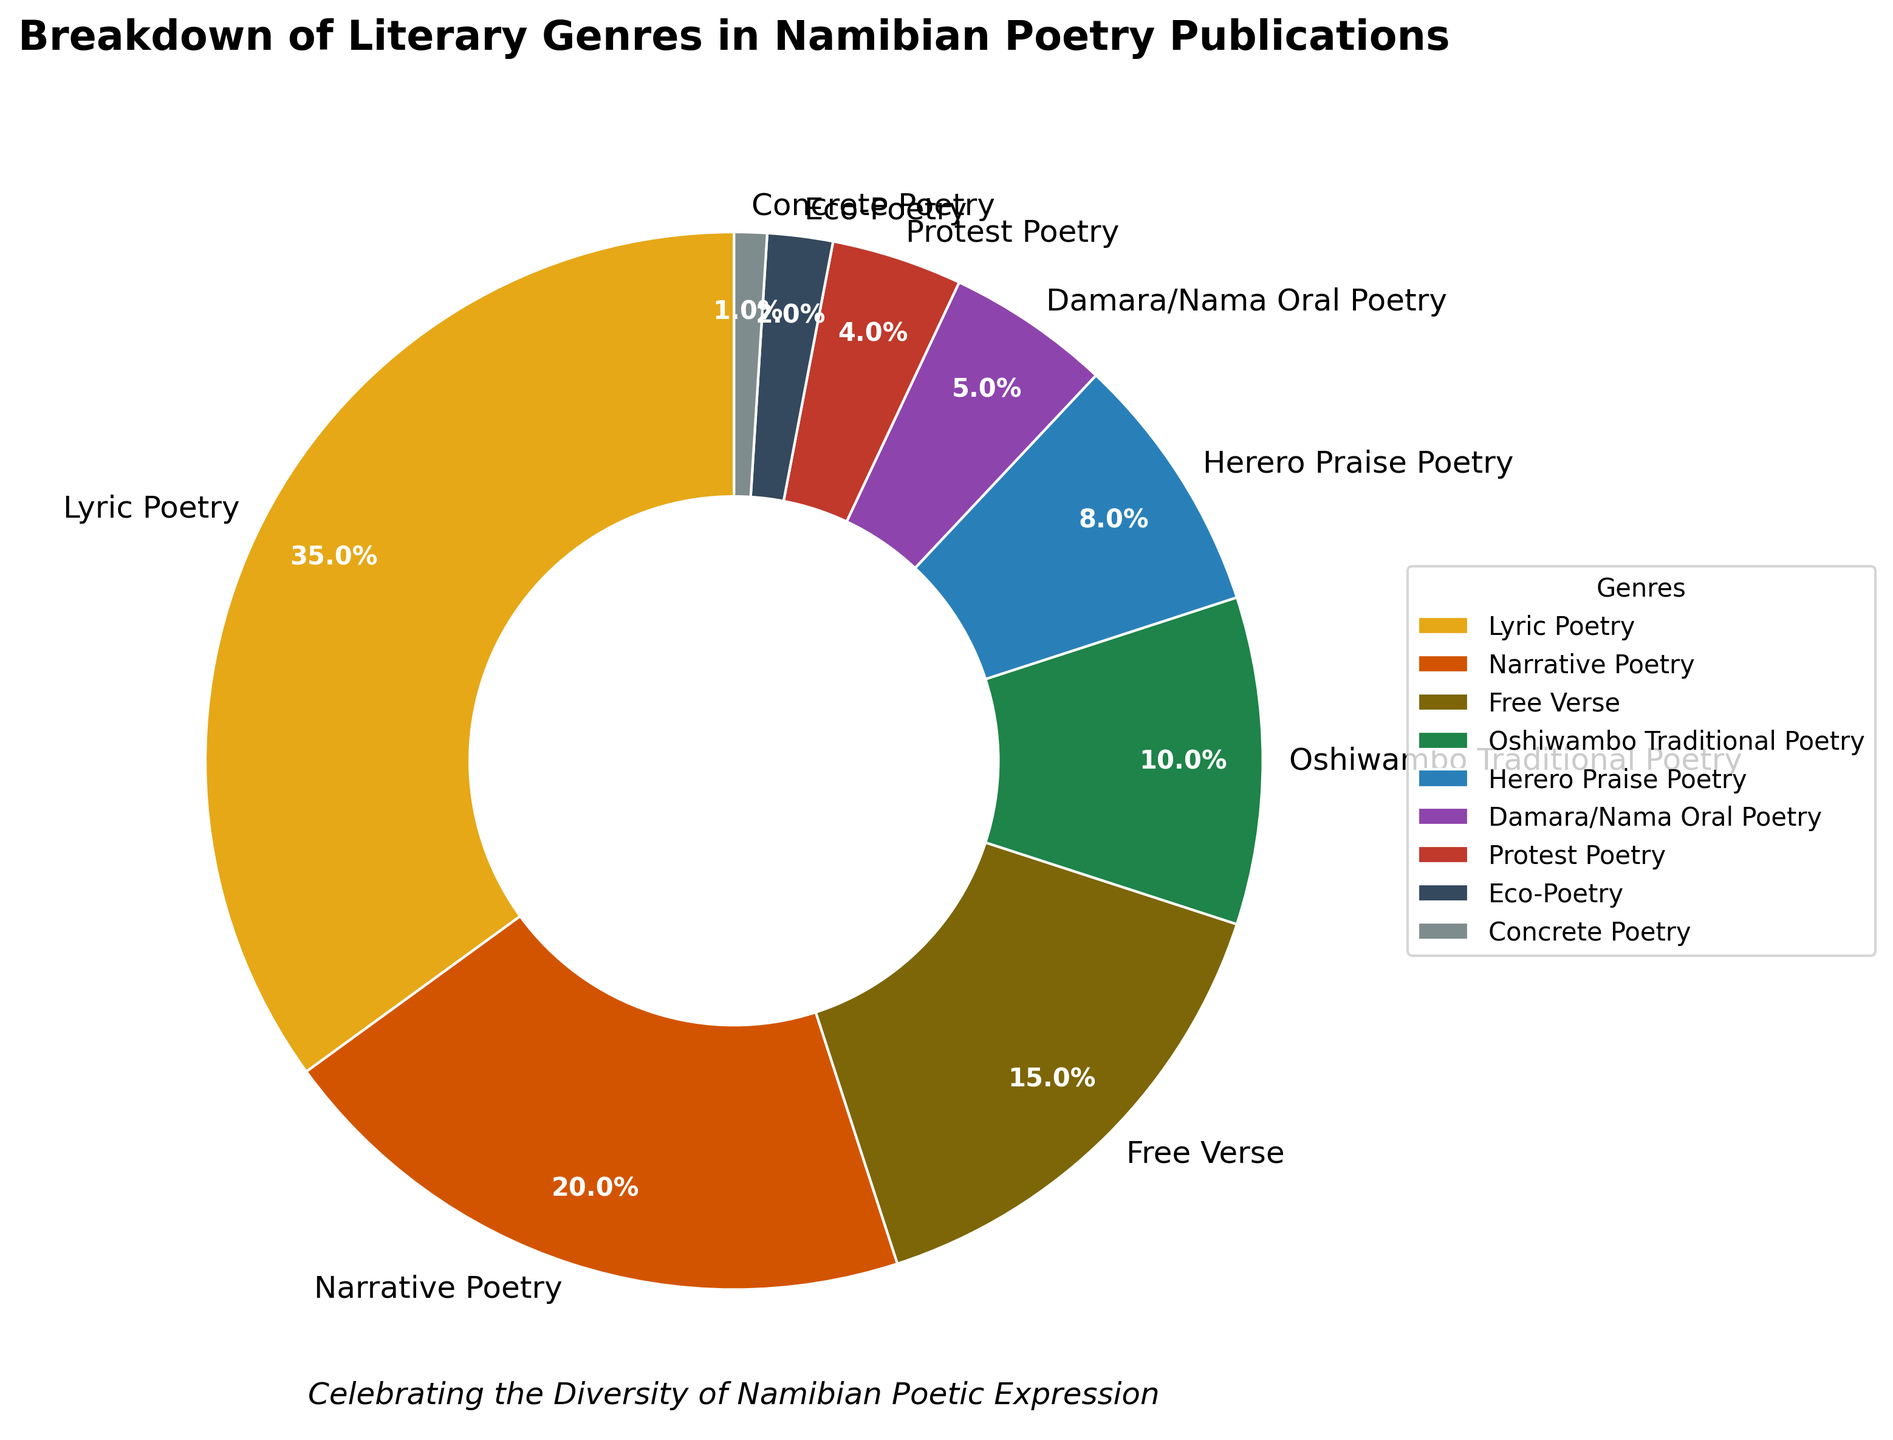What genre has the highest percentage in Namibian poetry publications? The pie chart shows that Lyric Poetry, with 35%, has the highest percentage.
Answer: Lyric Poetry Which genre has the smallest share in the poetry publications? The pie chart indicates that Concrete Poetry, at 1%, has the smallest share.
Answer: Concrete Poetry What is the combined percentage of Oshiwambo Traditional Poetry and Herero Praise Poetry? Summing the percentages of Oshiwambo Traditional Poetry (10%) and Herero Praise Poetry (8%) gives 10 + 8 = 18%.
Answer: 18% If you combine Eco-Poetry and Damara/Nama Oral Poetry, do they still have a smaller share than Free Verse? The combined percentage of Eco-Poetry (2%) and Damara/Nama Oral Poetry (5%) is 2 + 5 = 7%, which is indeed smaller than Free Verse's 15%.
Answer: Yes How does the size of the section representing Narrative Poetry compare to that of Protest Poetry? Narrative Poetry, with 20%, has a section much larger than Protest Poetry's 4%.
Answer: Narrative Poetry's section is larger Is the combined percentage of Protest Poetry and Concrete Poetry equal to the percentage of any other single genre? Adding Protest Poetry (4%) and Concrete Poetry (1%) gives 4 + 1 = 5%, which matches Damara/Nama Oral Poetry's 5%.
Answer: Damara/Nama Oral Poetry Describe the visual attributes of the segment representing Eco-Poetry. The segment representing Eco-Poetry is small, placed in the green color range, and occupies 2% of the pie chart.
Answer: Small, green, 2% Which genre has a larger share, Oshiwambo Traditional Poetry or Herero Praise Poetry, and by how much? Oshiwambo Traditional Poetry has 10% and Herero Praise Poetry has 8%; the difference is 10 - 8 = 2%.
Answer: Oshiwambo Traditional Poetry, by 2% What is the total percentage of genres that are higher than 5%? Summing the percentages of Lyric Poetry (35%), Narrative Poetry (20%), Free Verse (15%), Oshiwambo Traditional Poetry (10%), and Herero Praise Poetry (8%) gives 88%.
Answer: 88% Of the two smallest genres, which one has double the share of the other? Concrete Poetry is 1% and Eco-Poetry is 2%; Eco-Poetry has double the share of Concrete Poetry.
Answer: Eco-Poetry 